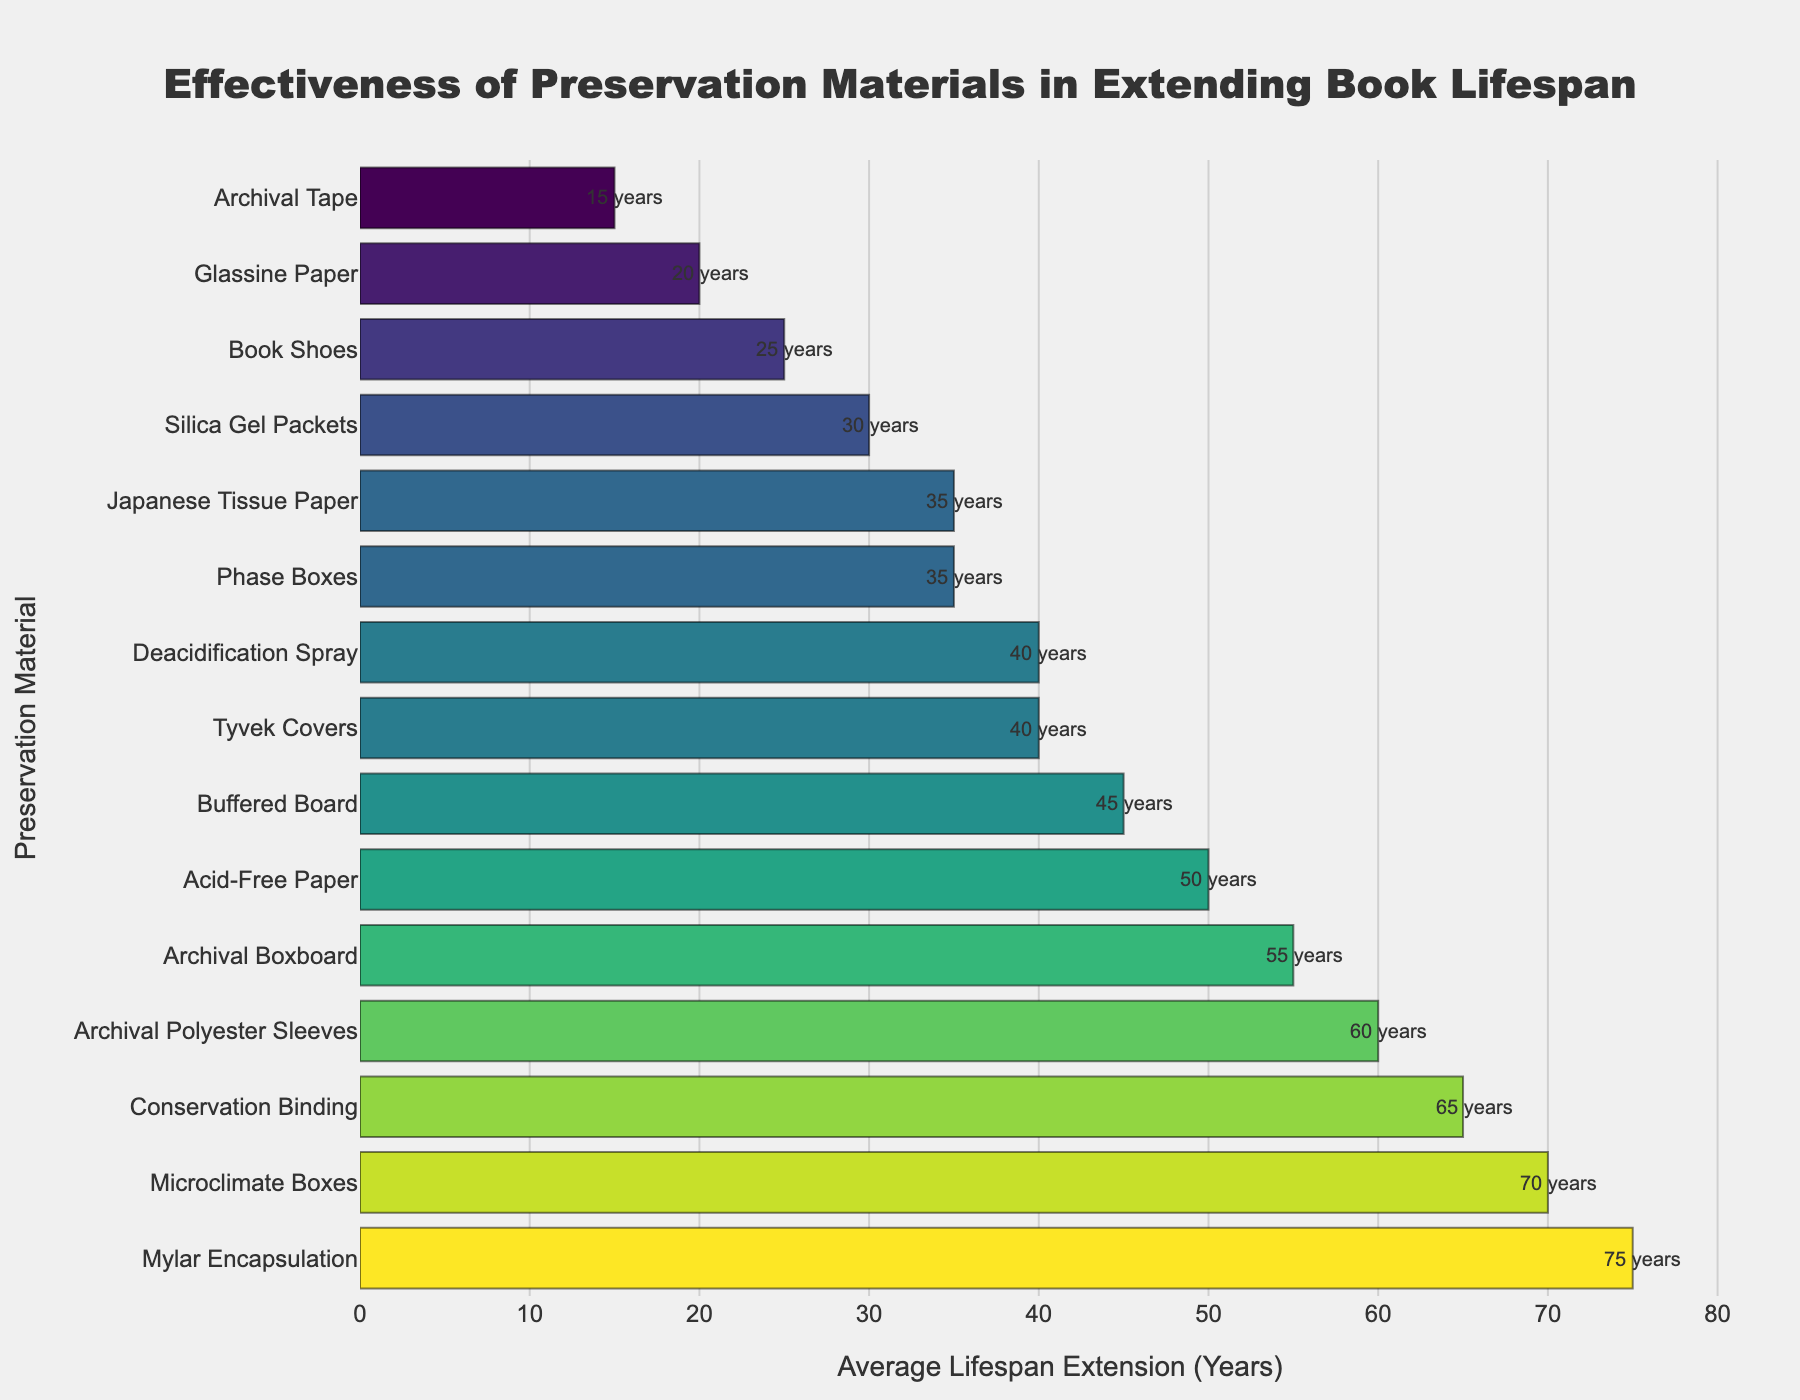Which preservation material extends the book lifespan the most? The bar with the greatest length represents the preservation material with the highest effectiveness. In this case, "Mylar Encapsulation" has the longest bar, indicating the highest lifespan extension.
Answer: Mylar Encapsulation Which preservation material extends the book lifespan the least? The bar with the shortest length represents the preservation material with the lowest effectiveness. "Archival Tape" has the shortest bar on the chart.
Answer: Archival Tape How many preservation materials extend the book lifespan by more than 50 years? Count the number of bars that extend beyond the 50-year mark on the x-axis. These are: Acid-Free Paper, Mylar Encapsulation, Archival Polyester Sleeves, Conservation Binding, Microclimate Boxes, and Archival Boxboard.
Answer: 6 What is the difference in lifespan extension between Microclimate Boxes and Phase Boxes? Find the bars representing Microclimate Boxes and Phase Boxes, then subtract the height of the Phase Boxes bar from the height of the Microclimate Boxes bar: 70 years - 35 years = 35 years.
Answer: 35 years Which preservation material is more effective: Tyvek Covers or Deacidification Spray? Compare the lengths of the bars for Tyvek Covers and Deacidification Spray. Tyvek Covers extend the lifespan by 40 years, whereas Deacidification Spray also extends it by 40 years.
Answer: They are equally effective How much longer does Conservation Binding extend book lifespan compared to Book Shoes? Identify the bars for Conservation Binding and Book Shoes, then subtract the height of the Book Shoes bar from the height of the Conservation Binding bar: 65 years - 25 years = 40 years.
Answer: 40 years Which preservation materials have an average lifespan extension of exactly 35 years? Identify the bars that show a lifespan extension of exactly 35 years. These are Phase Boxes and Japanese Tissue Paper.
Answer: Phase Boxes, Japanese Tissue Paper Is there a preservation material that extends the book lifespan by exactly 45 years? Check if there is any bar that corresponds to a lifespan extension of exactly 45 years. Buffered Board extends the lifespan by 45 years.
Answer: Buffered Board What's the average lifespan extension of the top 3 most effective preservation materials? Add up the lifespan extensions of the top 3 materials (Mylar Encapsulation - 75 years, Microclimate Boxes - 70 years, Conservation Binding - 65 years) and divide by 3: (75 + 70 + 65) / 3 = 70 years.
Answer: 70 years 